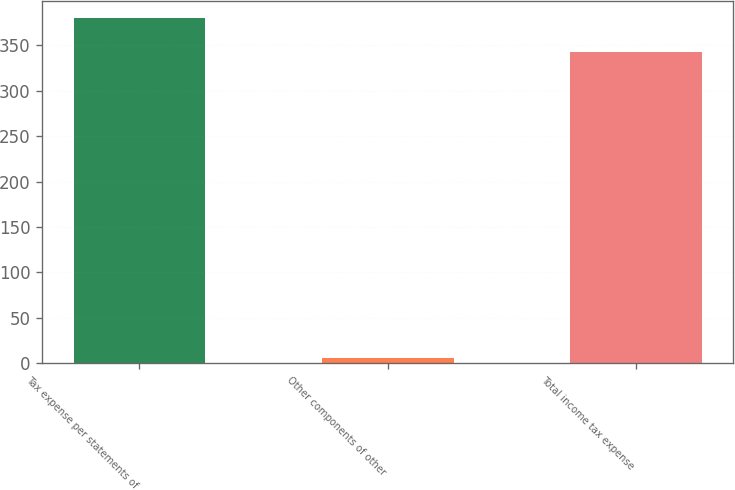<chart> <loc_0><loc_0><loc_500><loc_500><bar_chart><fcel>Tax expense per statements of<fcel>Other components of other<fcel>Total income tax expense<nl><fcel>380.4<fcel>5<fcel>343<nl></chart> 